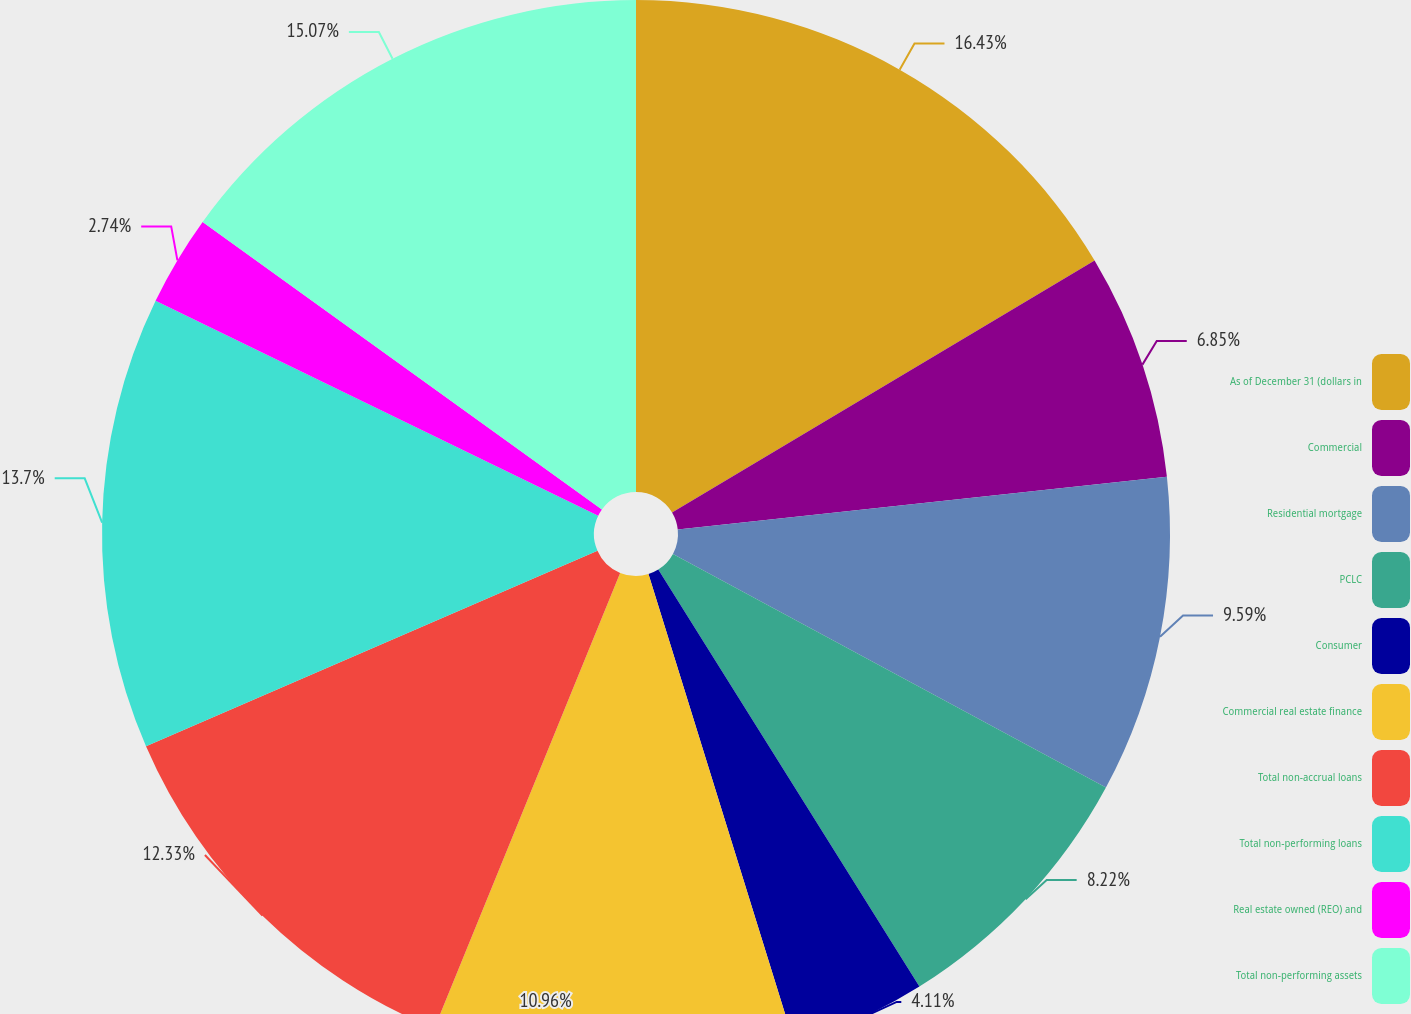<chart> <loc_0><loc_0><loc_500><loc_500><pie_chart><fcel>As of December 31 (dollars in<fcel>Commercial<fcel>Residential mortgage<fcel>PCLC<fcel>Consumer<fcel>Commercial real estate finance<fcel>Total non-accrual loans<fcel>Total non-performing loans<fcel>Real estate owned (REO) and<fcel>Total non-performing assets<nl><fcel>16.44%<fcel>6.85%<fcel>9.59%<fcel>8.22%<fcel>4.11%<fcel>10.96%<fcel>12.33%<fcel>13.7%<fcel>2.74%<fcel>15.07%<nl></chart> 